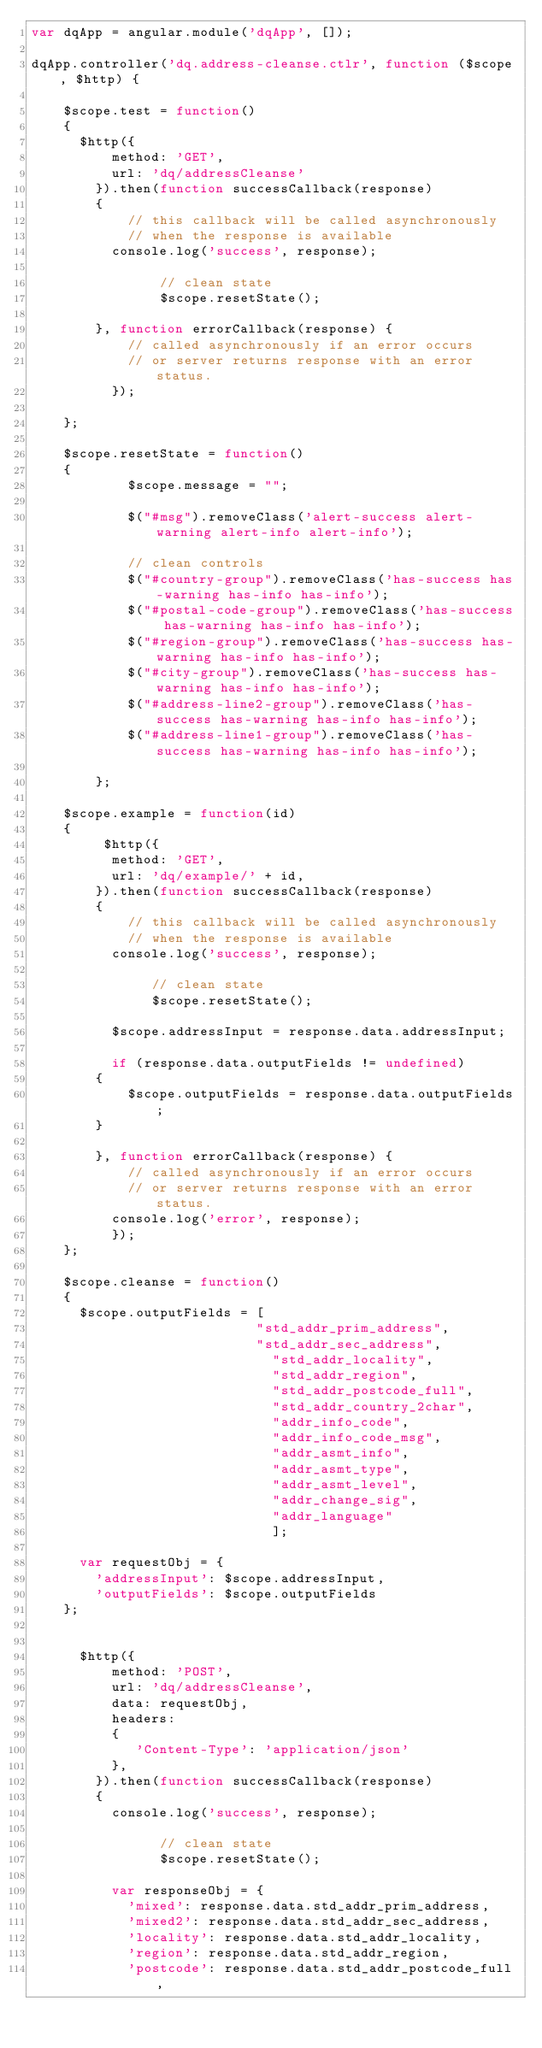<code> <loc_0><loc_0><loc_500><loc_500><_JavaScript_>var dqApp = angular.module('dqApp', []);

dqApp.controller('dq.address-cleanse.ctlr', function ($scope, $http) {
    
    $scope.test = function() 
    {
    	$http({
    		  method: 'GET',
    		  url: 'dq/addressCleanse'
    		}).then(function successCallback(response) 
    		{
    		    // this callback will be called asynchronously
    		    // when the response is available
    			console.log('success', response);
            
                // clean state
                $scope.resetState();
    			
    		}, function errorCallback(response) {
    		    // called asynchronously if an error occurs
    		    // or server returns response with an error status.
    		  });
    
    };
    
    $scope.resetState = function()
    {
            $scope.message = "";
            
            $("#msg").removeClass('alert-success alert-warning alert-info alert-info');
            
            // clean controls
            $("#country-group").removeClass('has-success has-warning has-info has-info');
            $("#postal-code-group").removeClass('has-success has-warning has-info has-info'); 
            $("#region-group").removeClass('has-success has-warning has-info has-info');
            $("#city-group").removeClass('has-success has-warning has-info has-info');
            $("#address-line2-group").removeClass('has-success has-warning has-info has-info');
            $("#address-line1-group").removeClass('has-success has-warning has-info has-info');
  
        };
    
    $scope.example = function(id) 
    {
    	   $http({
    		  method: 'GET',
    		  url: 'dq/example/' + id,
    		}).then(function successCallback(response) 
    		{
    		    // this callback will be called asynchronously
    		    // when the response is available
    			console.log('success', response);
               
               // clean state
               $scope.resetState();
               
    			$scope.addressInput = response.data.addressInput;
    			
    			if (response.data.outputFields != undefined)
				{
    				$scope.outputFields = response.data.outputFields;
				}

    		}, function errorCallback(response) {
    		    // called asynchronously if an error occurs
    		    // or server returns response with an error status.
    			console.log('error', response);
    		  });
    };
    
    $scope.cleanse = function() 
    {
    	$scope.outputFields = [
    	                    	"std_addr_prim_address",
    	                    	"std_addr_sec_address",
    	                      	"std_addr_locality", 
    	                      	"std_addr_region",
    	                      	"std_addr_postcode_full", 
    	                      	"std_addr_country_2char",
    	                      	"addr_info_code",
    	                        "addr_info_code_msg",
    	                        "addr_asmt_info",
    	                        "addr_asmt_type",
    	                        "addr_asmt_level",
    	                        "addr_change_sig",
    	                        "addr_language"
    	                        ];
    	
    	var requestObj = {
				'addressInput': $scope.addressInput,
				'outputFields': $scope.outputFields
		};
    	
    	
    	$http({
    		  method: 'POST',
    		  url: 'dq/addressCleanse',
    		  data: requestObj,
    		  headers: 
    		  {
    			   'Content-Type': 'application/json'
    		  },
    		}).then(function successCallback(response) 
    		{
    			console.log('success', response);
    			
                // clean state
                $scope.resetState();
            
    			var responseObj = {
    				'mixed': response.data.std_addr_prim_address,
    				'mixed2': response.data.std_addr_sec_address,
    				'locality': response.data.std_addr_locality,
    				'region': response.data.std_addr_region,
    				'postcode': response.data.std_addr_postcode_full,</code> 